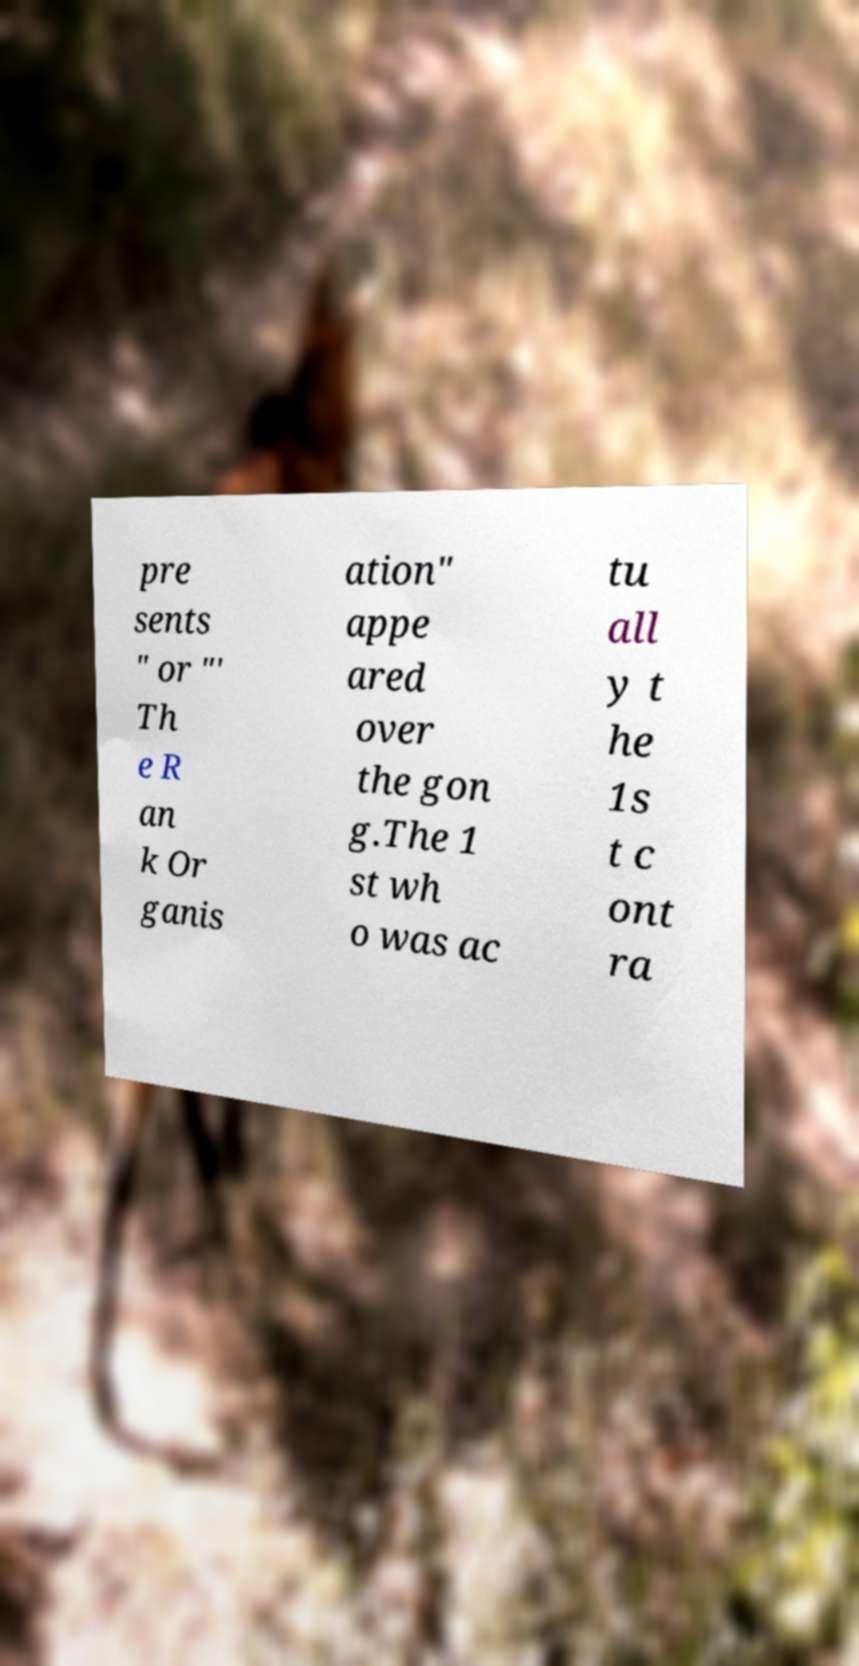What messages or text are displayed in this image? I need them in a readable, typed format. pre sents " or "' Th e R an k Or ganis ation" appe ared over the gon g.The 1 st wh o was ac tu all y t he 1s t c ont ra 